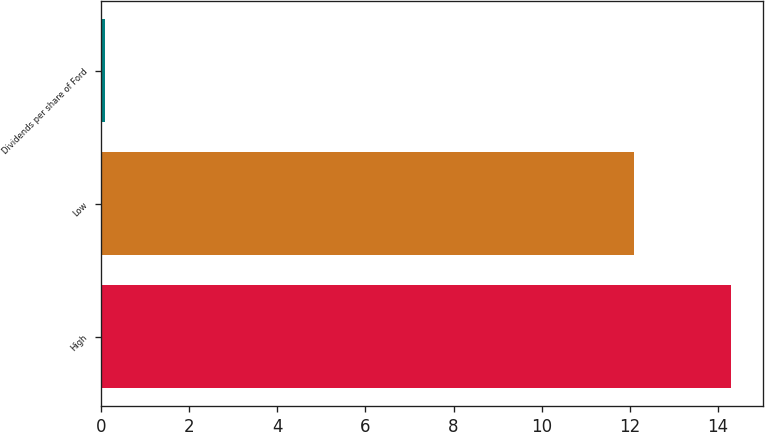Convert chart to OTSL. <chart><loc_0><loc_0><loc_500><loc_500><bar_chart><fcel>High<fcel>Low<fcel>Dividends per share of Ford<nl><fcel>14.3<fcel>12.1<fcel>0.1<nl></chart> 